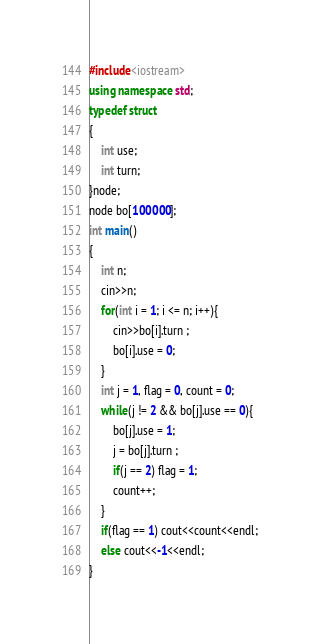<code> <loc_0><loc_0><loc_500><loc_500><_C++_>#include<iostream>
using namespace std;
typedef struct
{
	int use;
	int turn;
}node;
node bo[100000];
int main()
{
	int n;
	cin>>n;
	for(int i = 1; i <= n; i++){
		cin>>bo[i].turn ;
		bo[i].use = 0;
	}
	int j = 1, flag = 0, count = 0;
	while(j != 2 && bo[j].use == 0){
		bo[j].use = 1;
		j = bo[j].turn ;
		if(j == 2) flag = 1;
		count++;
	}
	if(flag == 1) cout<<count<<endl;
	else cout<<-1<<endl;
}</code> 